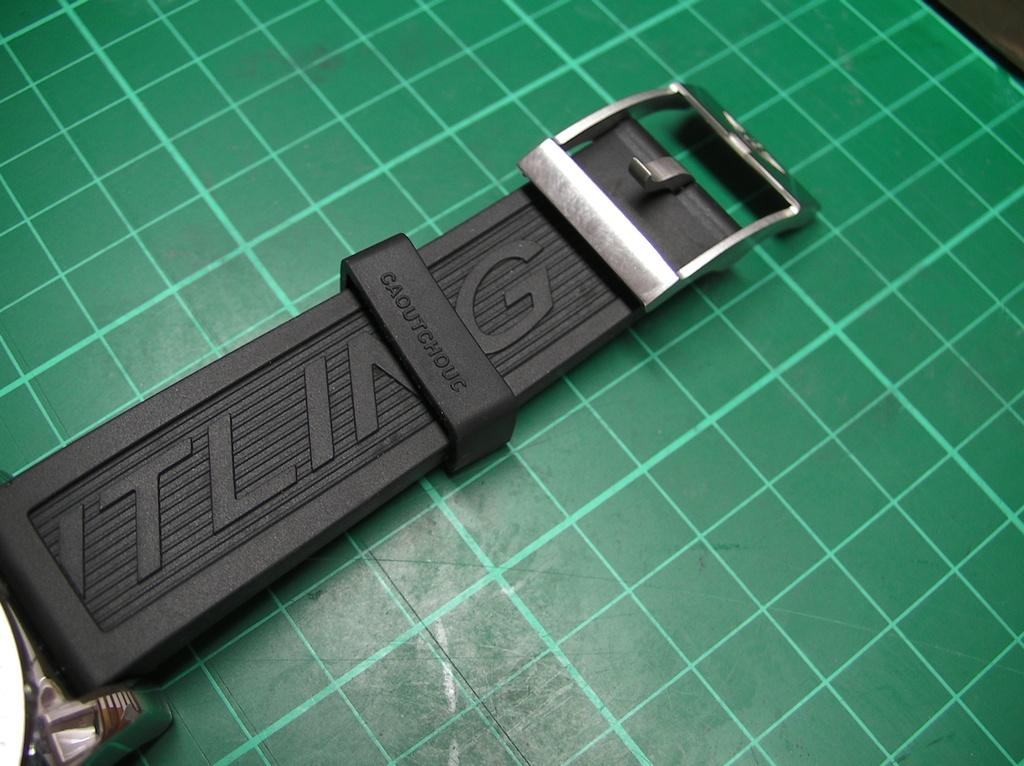<image>
Offer a succinct explanation of the picture presented. An ITLING buckle laying on a background that is green. 